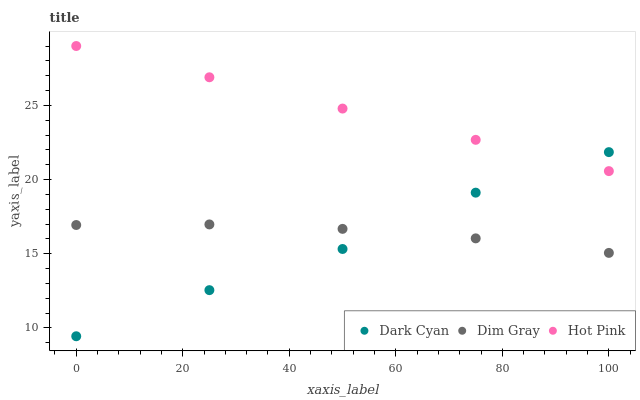Does Dark Cyan have the minimum area under the curve?
Answer yes or no. Yes. Does Hot Pink have the maximum area under the curve?
Answer yes or no. Yes. Does Dim Gray have the minimum area under the curve?
Answer yes or no. No. Does Dim Gray have the maximum area under the curve?
Answer yes or no. No. Is Hot Pink the smoothest?
Answer yes or no. Yes. Is Dark Cyan the roughest?
Answer yes or no. Yes. Is Dim Gray the smoothest?
Answer yes or no. No. Is Dim Gray the roughest?
Answer yes or no. No. Does Dark Cyan have the lowest value?
Answer yes or no. Yes. Does Dim Gray have the lowest value?
Answer yes or no. No. Does Hot Pink have the highest value?
Answer yes or no. Yes. Does Dim Gray have the highest value?
Answer yes or no. No. Is Dim Gray less than Hot Pink?
Answer yes or no. Yes. Is Hot Pink greater than Dim Gray?
Answer yes or no. Yes. Does Hot Pink intersect Dark Cyan?
Answer yes or no. Yes. Is Hot Pink less than Dark Cyan?
Answer yes or no. No. Is Hot Pink greater than Dark Cyan?
Answer yes or no. No. Does Dim Gray intersect Hot Pink?
Answer yes or no. No. 